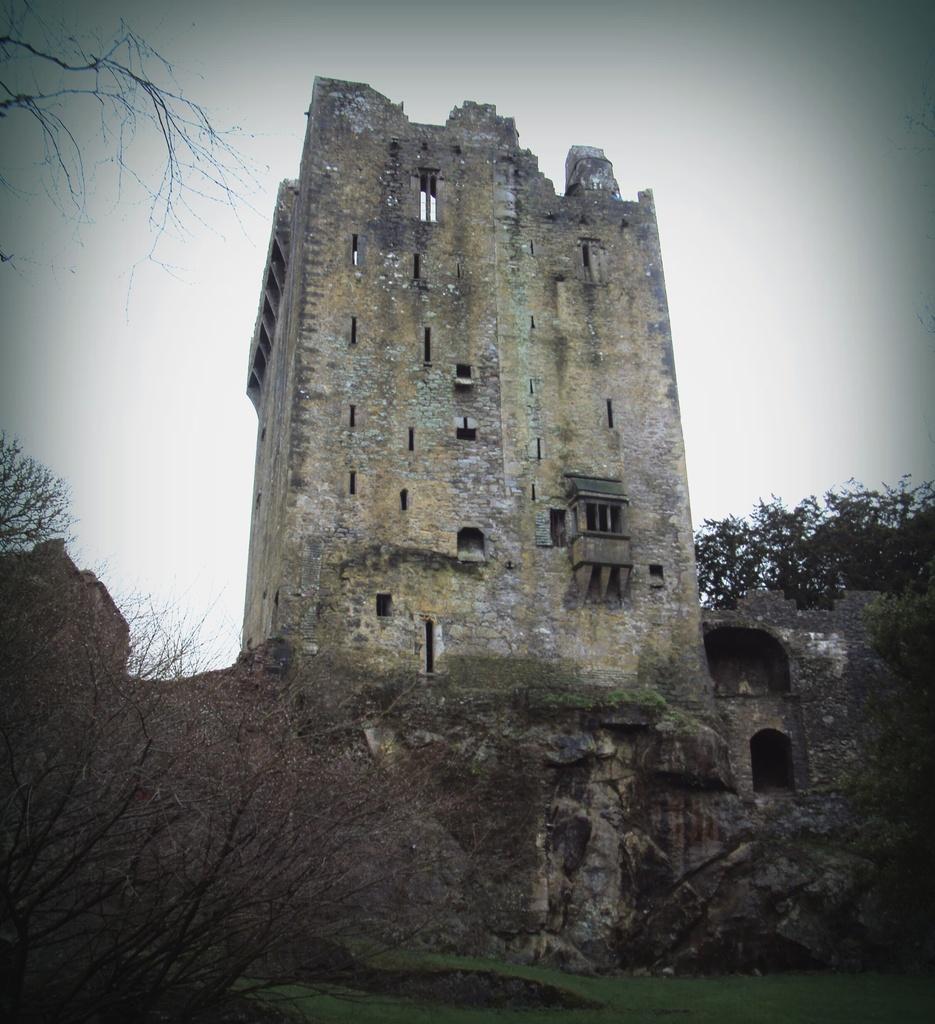Describe this image in one or two sentences. This is an outside view. At the bottom there are some trees and I can see the grass on the ground. In the middle of the image there is a building. At the top of the image I can see the sky. 